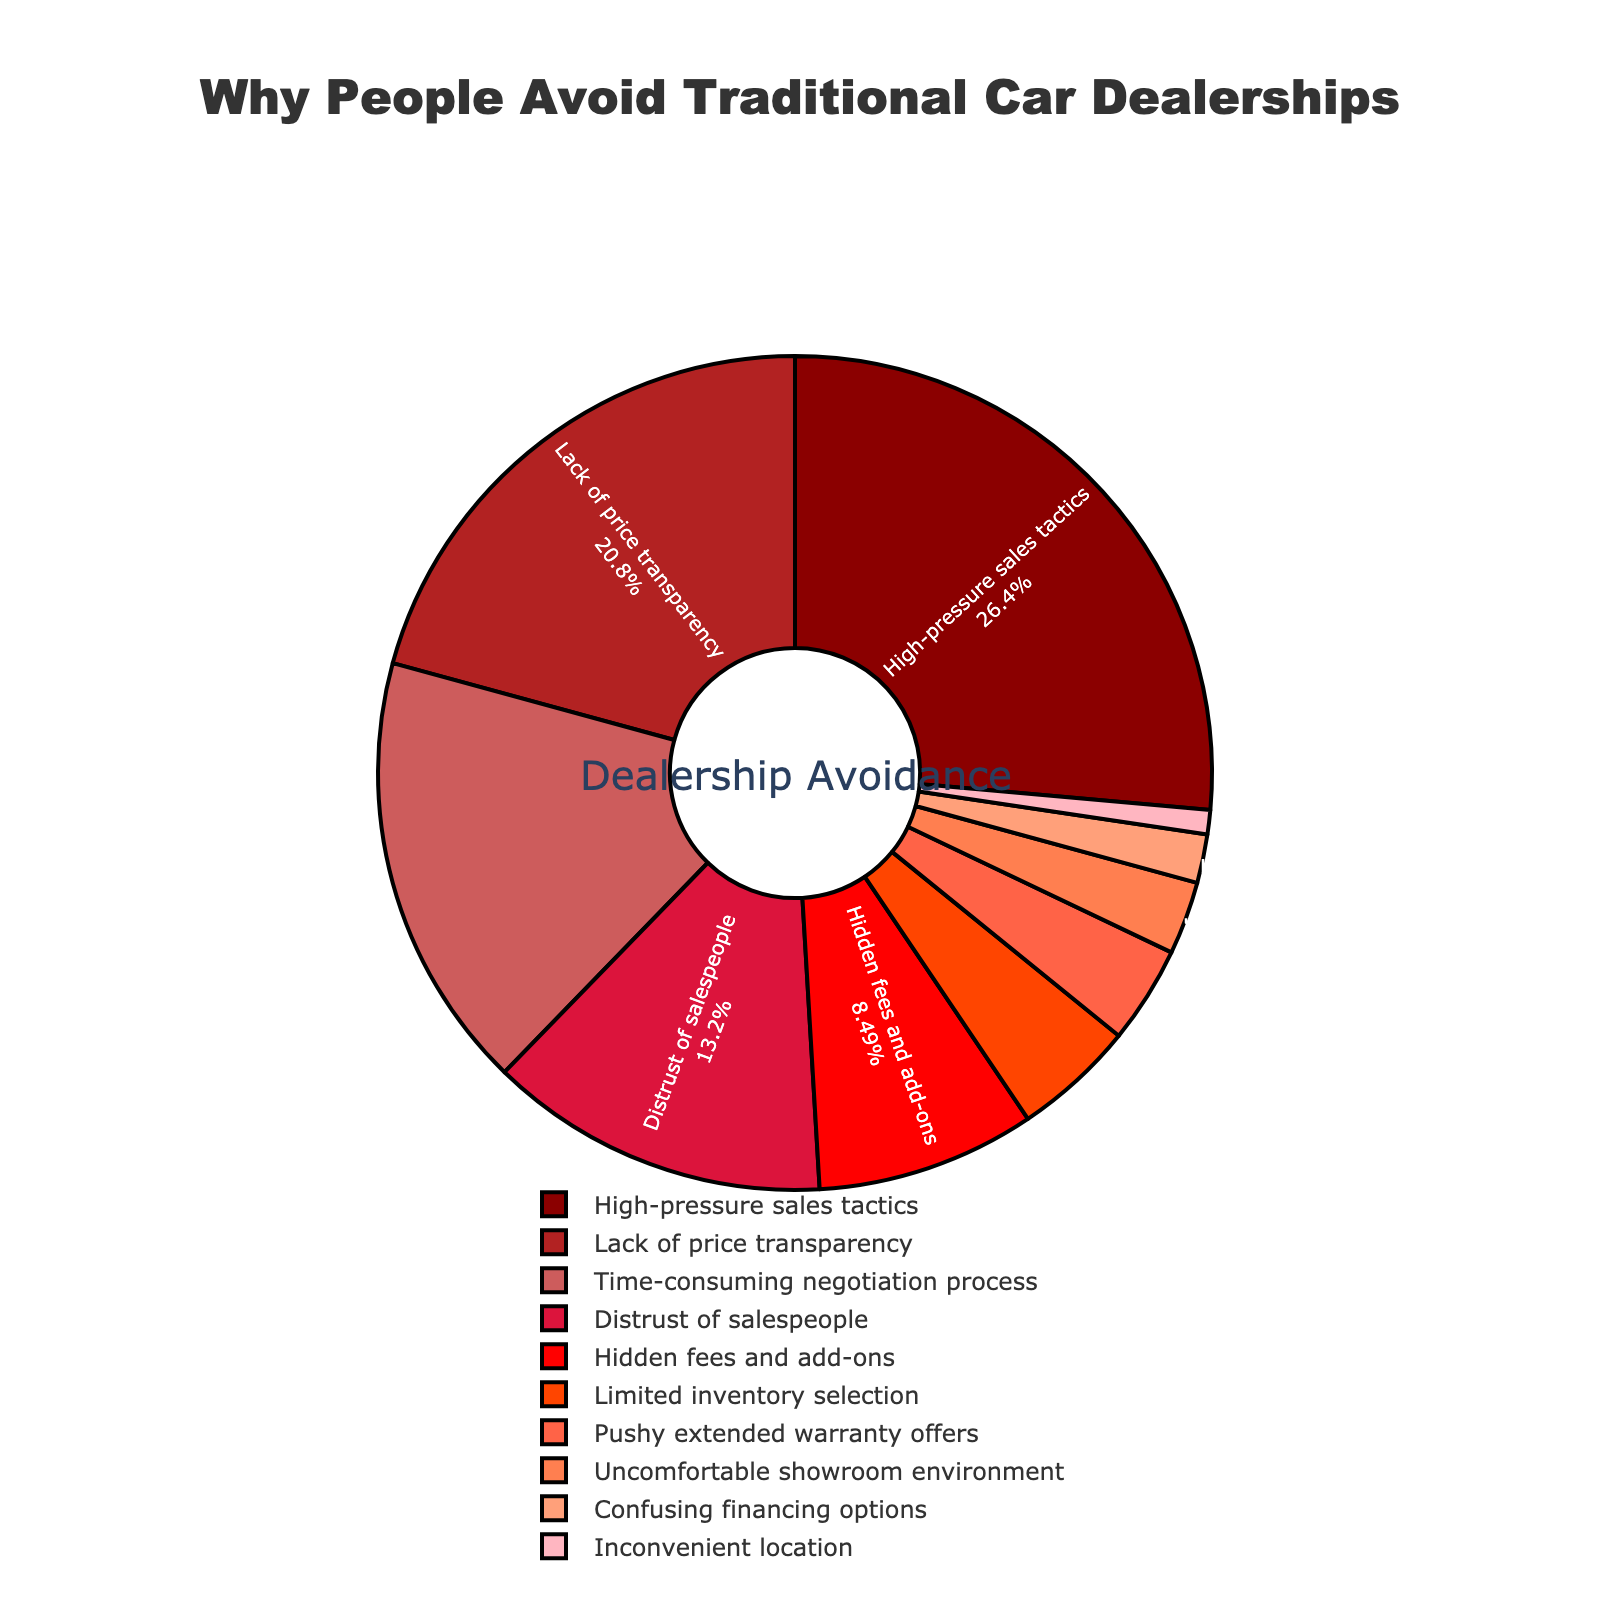Which reason has the highest percentage of people avoiding traditional car dealerships? The reason with the highest percentage is indicated by the largest slice in the pie chart.
Answer: High-pressure sales tactics What is the combined percentage of people avoiding car dealerships due to high-pressure sales tactics and lack of price transparency? Add the percentages of high-pressure sales tactics (28%) and lack of price transparency (22%). 28 + 22 = 50%
Answer: 50% Which two reasons together make up the smallest percentage of people avoiding car dealerships? Identify the two smallest slices in the pie chart and add their percentages. These are inconvenient location (1%) and confusing financing options (2%). 1 + 2 = 3%
Answer: Inconvenient location and confusing financing options How much higher is the percentage of people who avoid car dealerships due to distrust of salespeople compared to those who avoid them due to pushy extended warranty offers? Subtract the percentage of pushy extended warranty offers (4%) from the percentage of distrust of salespeople (14%). 14 - 4 = 10%
Answer: 10% If you combine the percentages of the three smallest reasons, do they make up more than or less than 10% of the total? Add the percentages of the three smallest reasons: inconvenient location (1%), confusing financing options (2%), and uncomfortable showroom environment (3%). 1 + 2 + 3 = 6%. Since 6% is less than 10%, they make up less than 10%.
Answer: Less than 10% What percentage of people avoid traditional car dealerships due to reasons related directly to financial aspects (lack of price transparency, hidden fees and add-ons, confusing financing options)? Add the percentages of lack of price transparency (22%), hidden fees and add-ons (9%), and confusing financing options (2%). 22 + 9 + 2 = 33%
Answer: 33% Are there more people avoiding car dealerships due to hidden fees and add-ons or limited inventory selection? Compare the two percentages: hidden fees and add-ons (9%) and limited inventory selection (5%). 9% is greater than 5%.
Answer: Hidden fees and add-ons Which reason related to the buying process (high-pressure sales tactics, time-consuming negotiation process, distrust of salespeople) has the least impact? Identify the smallest percentage among high-pressure sales tactics (28%), time-consuming negotiation process (18%), and distrust of salespeople (14%). Distrust of salespeople has the least impact at 14%.
Answer: Distrust of salespeople What is the percentage difference between the highest and lowest reasons people avoid traditional car dealerships? Subtract the percentage of the lowest reason (inconvenient location, 1%) from the highest reason (high-pressure sales tactics, 28%). 28 - 1 = 27%
Answer: 27% 